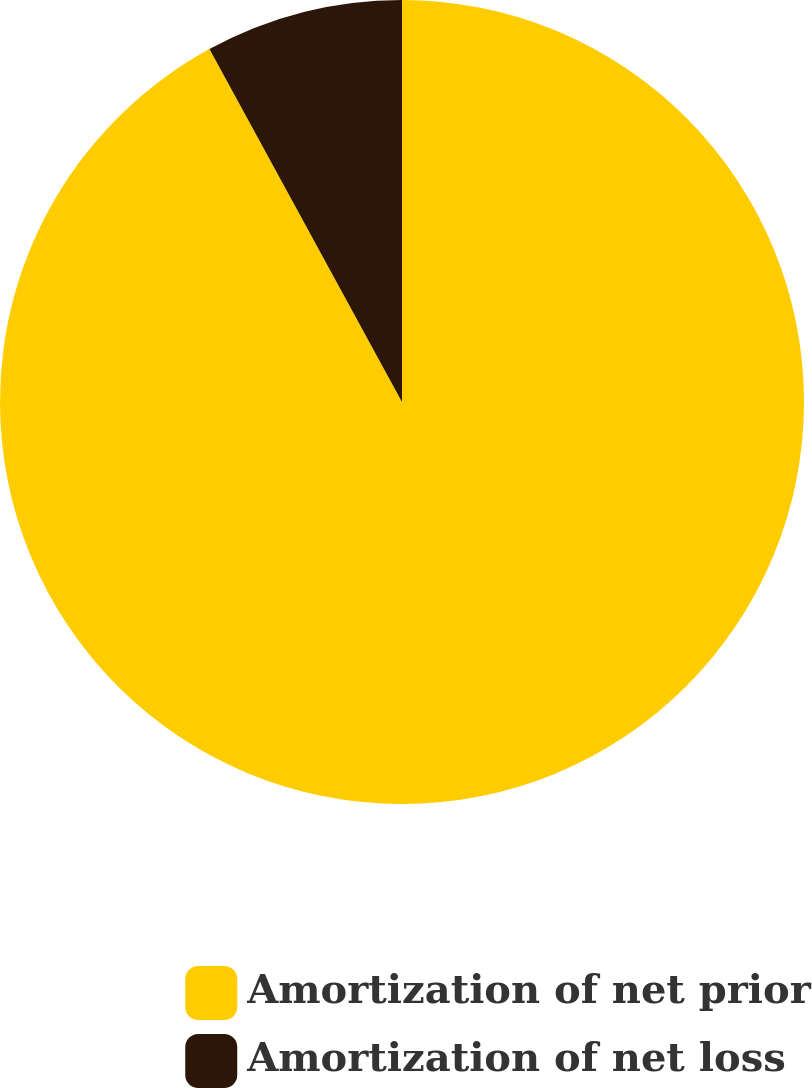Convert chart. <chart><loc_0><loc_0><loc_500><loc_500><pie_chart><fcel>Amortization of net prior<fcel>Amortization of net loss<nl><fcel>92.05%<fcel>7.95%<nl></chart> 